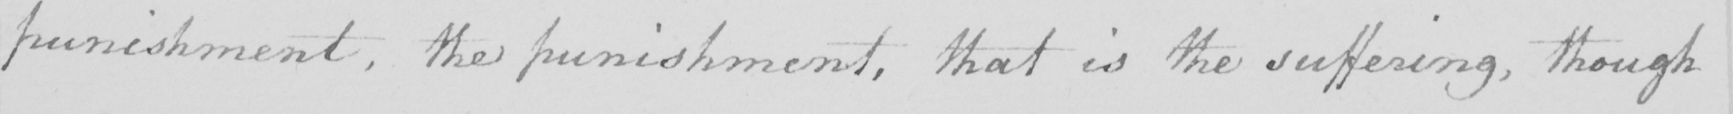What text is written in this handwritten line? punishment , the punishment , that is the suffering , though 